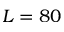Convert formula to latex. <formula><loc_0><loc_0><loc_500><loc_500>L = 8 0</formula> 